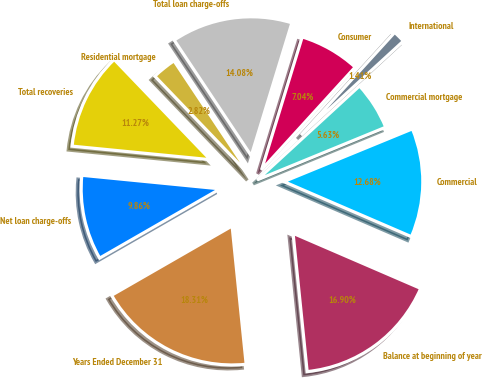<chart> <loc_0><loc_0><loc_500><loc_500><pie_chart><fcel>Years Ended December 31<fcel>Balance at beginning of year<fcel>Commercial<fcel>Commercial mortgage<fcel>International<fcel>Consumer<fcel>Total loan charge-offs<fcel>Residential mortgage<fcel>Total recoveries<fcel>Net loan charge-offs<nl><fcel>18.31%<fcel>16.9%<fcel>12.68%<fcel>5.63%<fcel>1.41%<fcel>7.04%<fcel>14.08%<fcel>2.82%<fcel>11.27%<fcel>9.86%<nl></chart> 